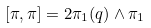Convert formula to latex. <formula><loc_0><loc_0><loc_500><loc_500>[ \pi , \pi ] = 2 \pi _ { 1 } ( q ) \wedge \pi _ { 1 }</formula> 